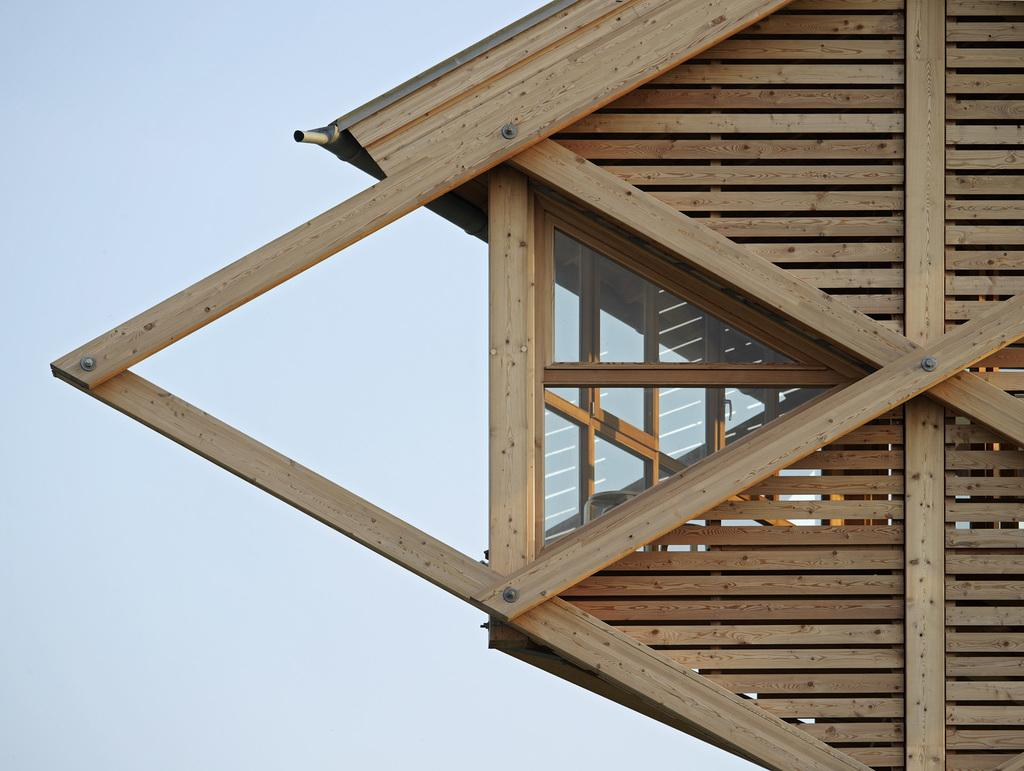What material is the house in the image made of? The house in the image is made with plywood. How much of the house can be seen in the image? The house is only partially visible in the image. What can be seen in the background of the image? The sky is visible in the image. Can you see any brushes being used to paint the house in the image? There is no indication of brushes or painting activity in the image. 